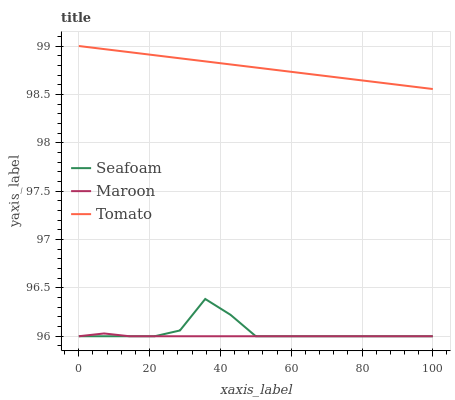Does Maroon have the minimum area under the curve?
Answer yes or no. Yes. Does Tomato have the maximum area under the curve?
Answer yes or no. Yes. Does Seafoam have the minimum area under the curve?
Answer yes or no. No. Does Seafoam have the maximum area under the curve?
Answer yes or no. No. Is Tomato the smoothest?
Answer yes or no. Yes. Is Seafoam the roughest?
Answer yes or no. Yes. Is Maroon the smoothest?
Answer yes or no. No. Is Maroon the roughest?
Answer yes or no. No. Does Tomato have the highest value?
Answer yes or no. Yes. Does Seafoam have the highest value?
Answer yes or no. No. Is Maroon less than Tomato?
Answer yes or no. Yes. Is Tomato greater than Seafoam?
Answer yes or no. Yes. Does Seafoam intersect Maroon?
Answer yes or no. Yes. Is Seafoam less than Maroon?
Answer yes or no. No. Is Seafoam greater than Maroon?
Answer yes or no. No. Does Maroon intersect Tomato?
Answer yes or no. No. 